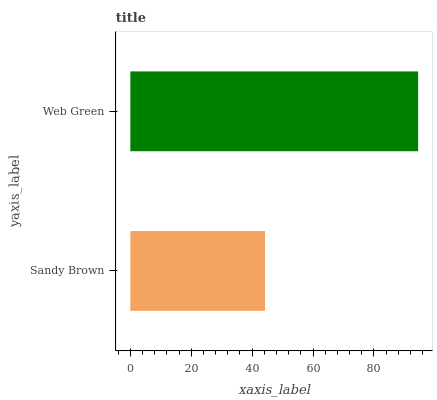Is Sandy Brown the minimum?
Answer yes or no. Yes. Is Web Green the maximum?
Answer yes or no. Yes. Is Web Green the minimum?
Answer yes or no. No. Is Web Green greater than Sandy Brown?
Answer yes or no. Yes. Is Sandy Brown less than Web Green?
Answer yes or no. Yes. Is Sandy Brown greater than Web Green?
Answer yes or no. No. Is Web Green less than Sandy Brown?
Answer yes or no. No. Is Web Green the high median?
Answer yes or no. Yes. Is Sandy Brown the low median?
Answer yes or no. Yes. Is Sandy Brown the high median?
Answer yes or no. No. Is Web Green the low median?
Answer yes or no. No. 